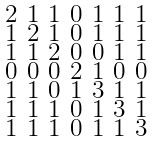<formula> <loc_0><loc_0><loc_500><loc_500>\begin{smallmatrix} 2 & 1 & 1 & 0 & 1 & 1 & 1 \\ 1 & 2 & 1 & 0 & 1 & 1 & 1 \\ 1 & 1 & 2 & 0 & 0 & 1 & 1 \\ 0 & 0 & 0 & 2 & 1 & 0 & 0 \\ 1 & 1 & 0 & 1 & 3 & 1 & 1 \\ 1 & 1 & 1 & 0 & 1 & 3 & 1 \\ 1 & 1 & 1 & 0 & 1 & 1 & 3 \end{smallmatrix}</formula> 